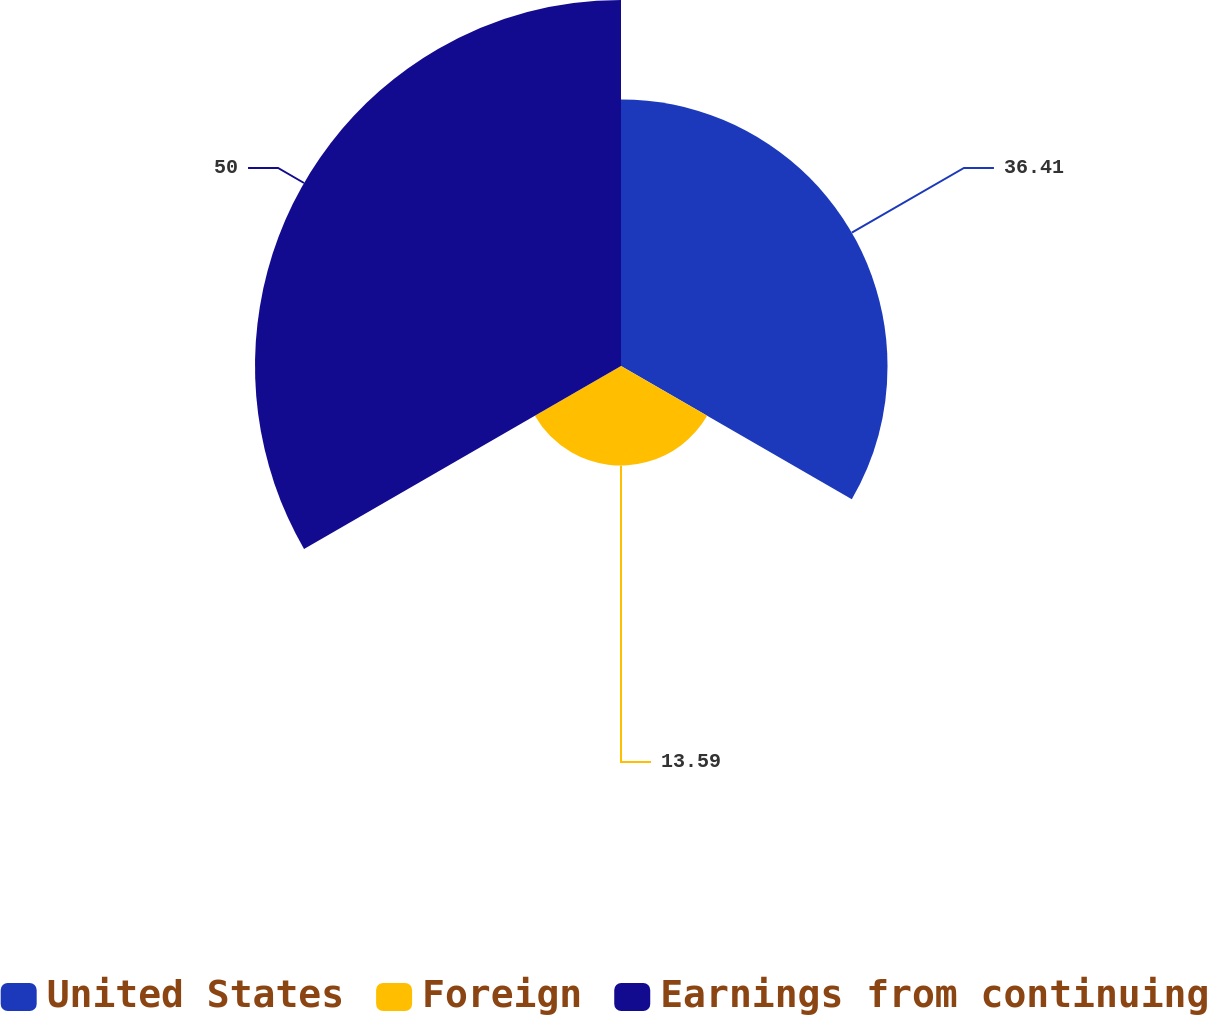Convert chart to OTSL. <chart><loc_0><loc_0><loc_500><loc_500><pie_chart><fcel>United States<fcel>Foreign<fcel>Earnings from continuing<nl><fcel>36.41%<fcel>13.59%<fcel>50.0%<nl></chart> 